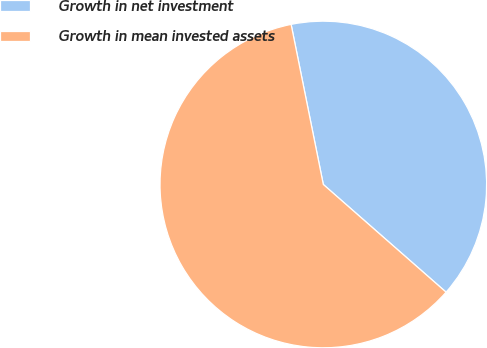Convert chart. <chart><loc_0><loc_0><loc_500><loc_500><pie_chart><fcel>Growth in net investment<fcel>Growth in mean invested assets<nl><fcel>39.62%<fcel>60.38%<nl></chart> 